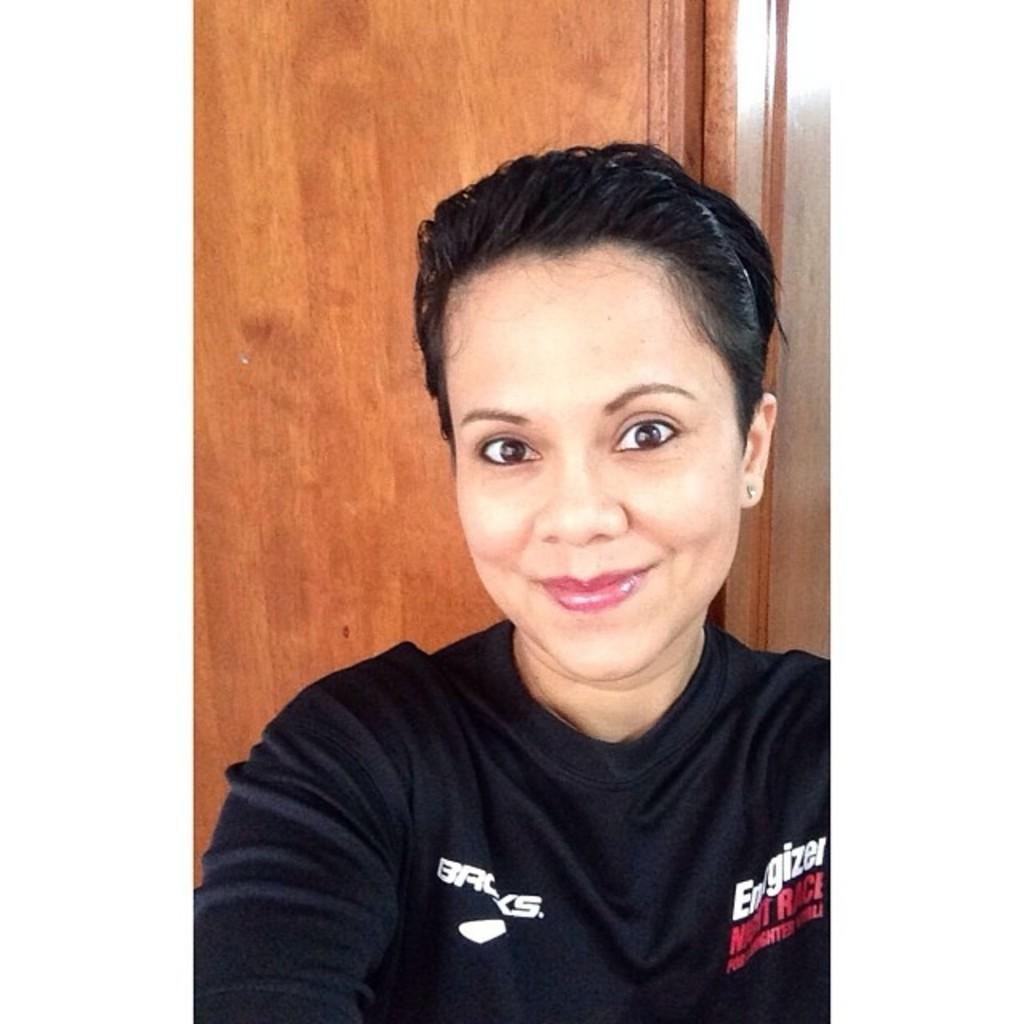<image>
Share a concise interpretation of the image provided. A woman is wearing a black shirt with the word Energizer on it. 